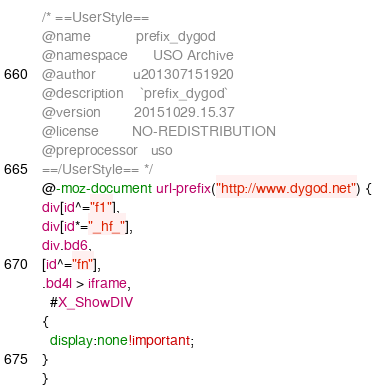Convert code to text. <code><loc_0><loc_0><loc_500><loc_500><_CSS_>/* ==UserStyle==
@name           prefix_dygod
@namespace      USO Archive
@author         u201307151920
@description    `prefix_dygod`
@version        20151029.15.37
@license        NO-REDISTRIBUTION
@preprocessor   uso
==/UserStyle== */
@-moz-document url-prefix("http://www.dygod.net") {
div[id^="f1"],
div[id*="_hf_"],
div.bd6,
[id^="fn"],
.bd4l > iframe,
  #X_ShowDIV
{
  display:none!important;
}
}</code> 